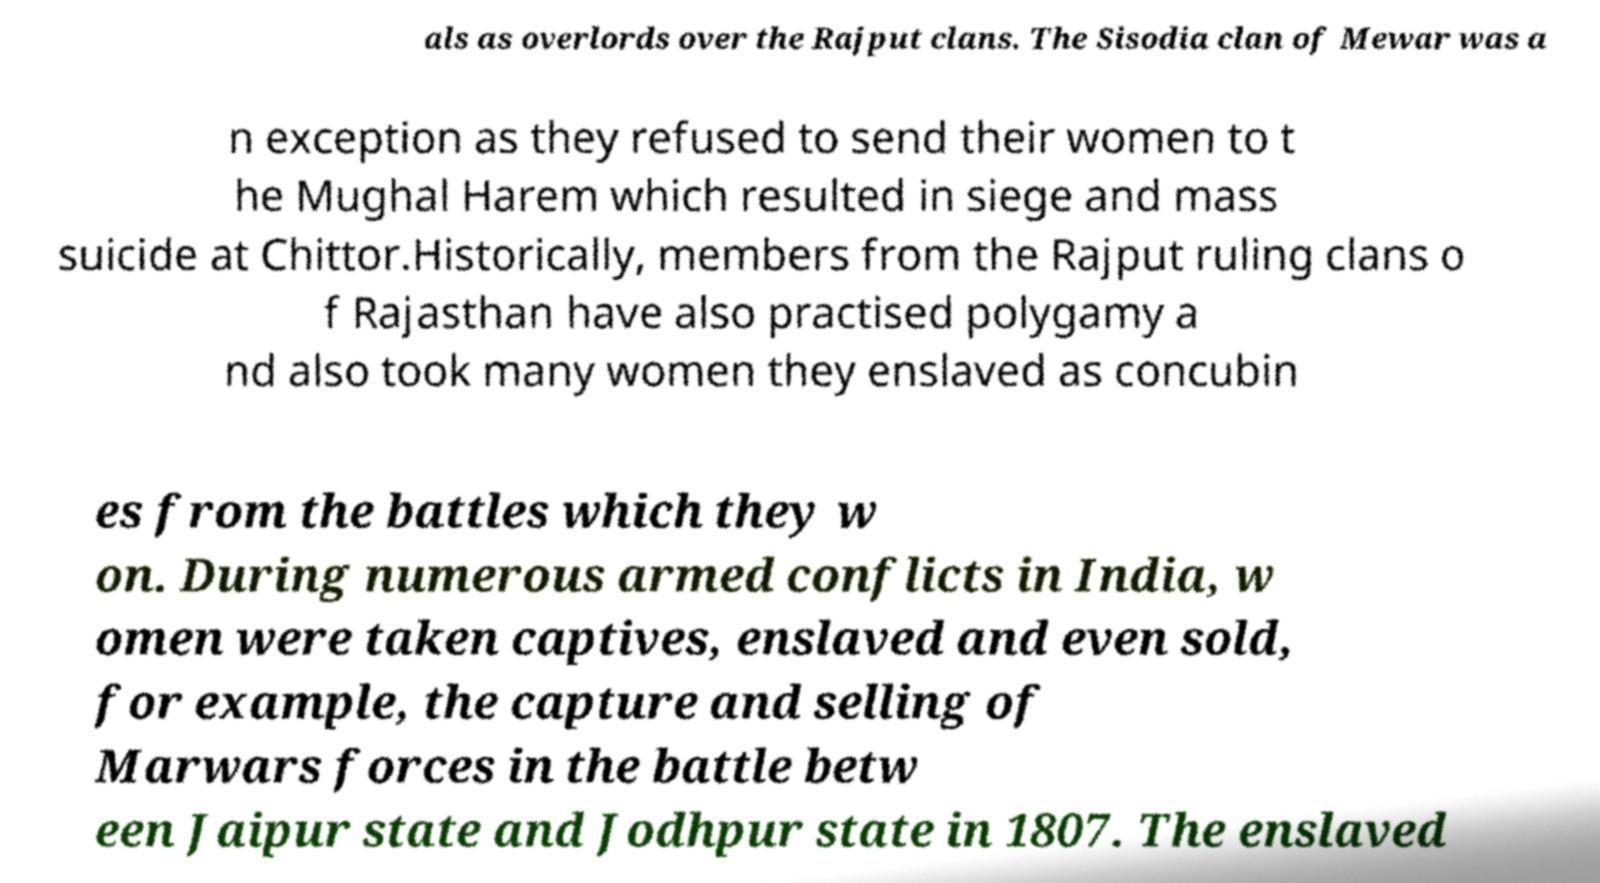Could you extract and type out the text from this image? als as overlords over the Rajput clans. The Sisodia clan of Mewar was a n exception as they refused to send their women to t he Mughal Harem which resulted in siege and mass suicide at Chittor.Historically, members from the Rajput ruling clans o f Rajasthan have also practised polygamy a nd also took many women they enslaved as concubin es from the battles which they w on. During numerous armed conflicts in India, w omen were taken captives, enslaved and even sold, for example, the capture and selling of Marwars forces in the battle betw een Jaipur state and Jodhpur state in 1807. The enslaved 